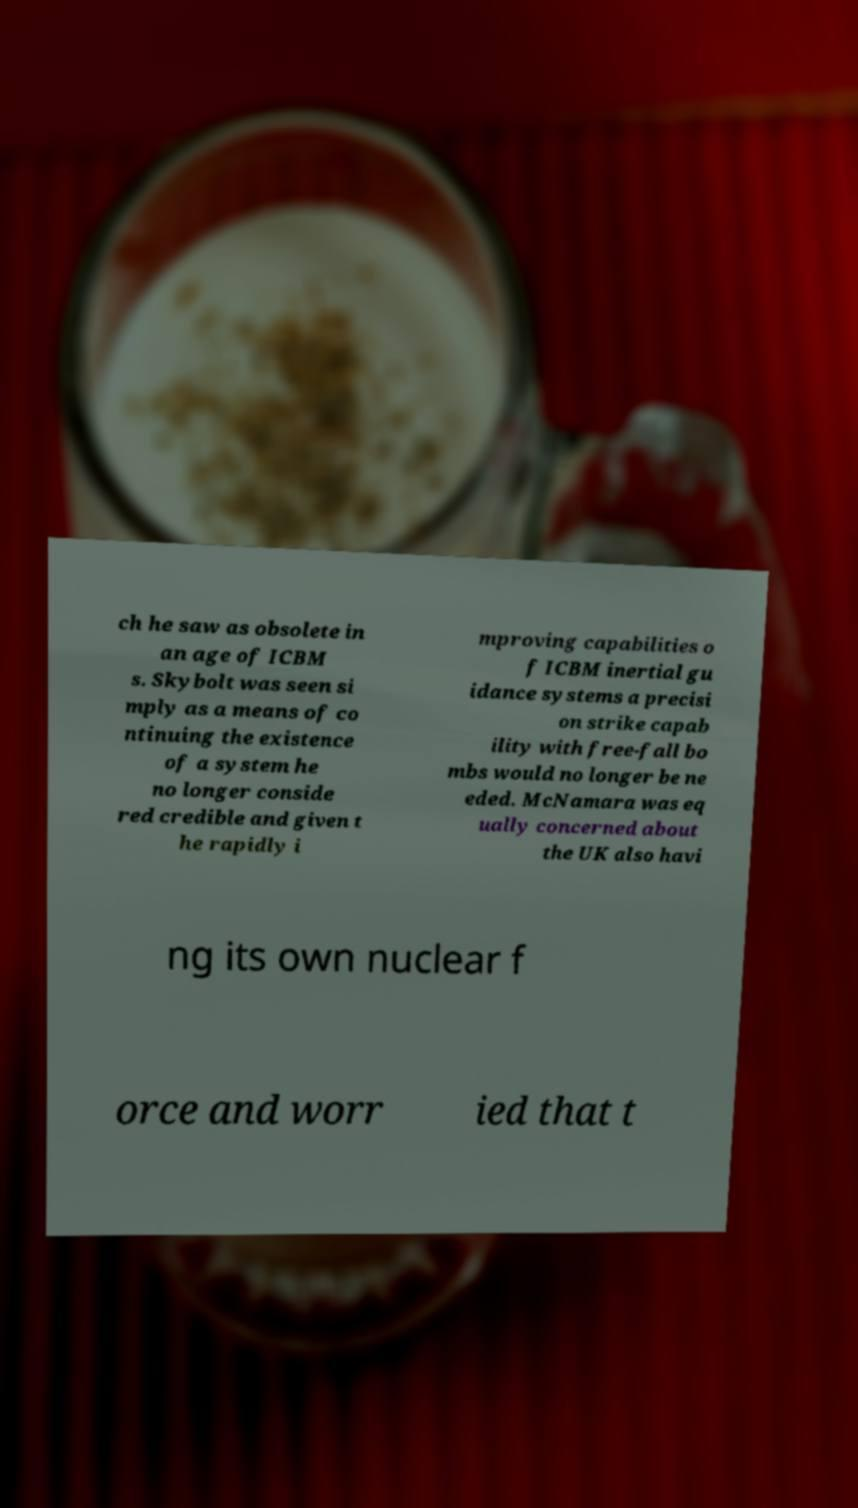What messages or text are displayed in this image? I need them in a readable, typed format. ch he saw as obsolete in an age of ICBM s. Skybolt was seen si mply as a means of co ntinuing the existence of a system he no longer conside red credible and given t he rapidly i mproving capabilities o f ICBM inertial gu idance systems a precisi on strike capab ility with free-fall bo mbs would no longer be ne eded. McNamara was eq ually concerned about the UK also havi ng its own nuclear f orce and worr ied that t 